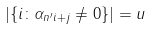Convert formula to latex. <formula><loc_0><loc_0><loc_500><loc_500>| \{ i \colon \alpha _ { n ^ { \prime } i + j } \neq 0 \} | = u</formula> 